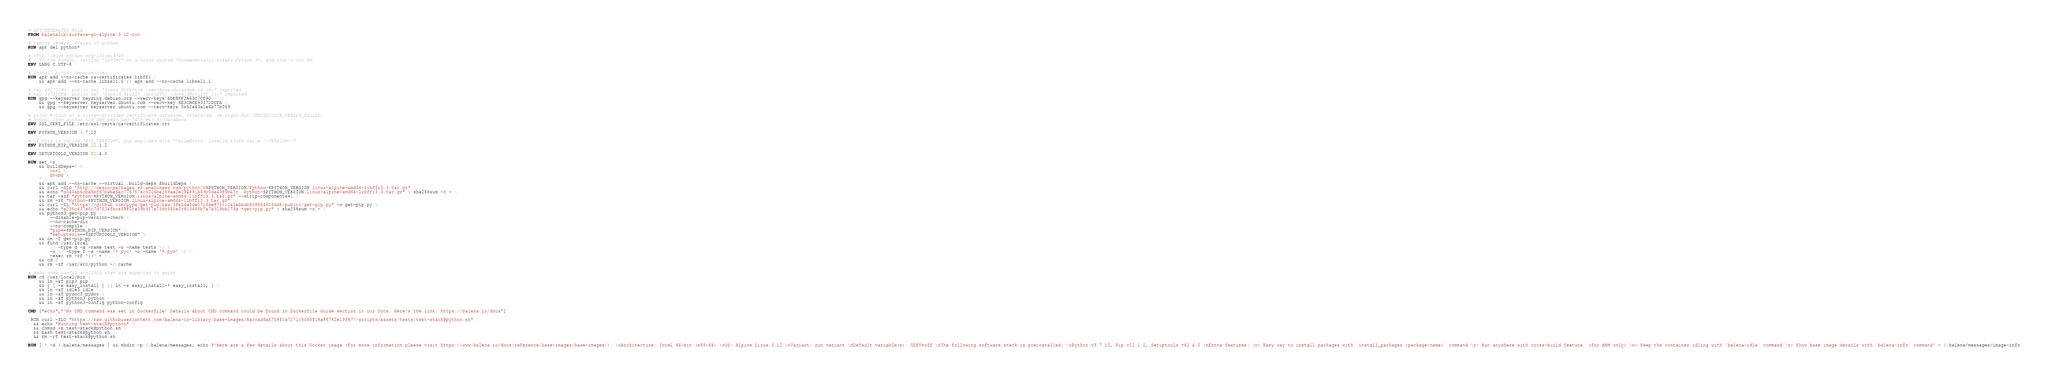Convert code to text. <code><loc_0><loc_0><loc_500><loc_500><_Dockerfile_># AUTOGENERATED FILE
FROM balenalib/surface-go-alpine:3.12-run

# remove several traces of python
RUN apk del python*

# http://bugs.python.org/issue19846
# > At the moment, setting "LANG=C" on a Linux system *fundamentally breaks Python 3*, and that's not OK.
ENV LANG C.UTF-8

# install python dependencies
RUN apk add --no-cache ca-certificates libffi \
	&& apk add --no-cache libssl1.0 || apk add --no-cache libssl1.1

# key 63C7CC90: public key "Simon McVittie <smcv@pseudorandom.co.uk>" imported
# key 3372DCFA: public key "Donald Stufft (dstufft) <donald@stufft.io>" imported
RUN gpg --keyserver keyring.debian.org --recv-keys 4DE8FF2A63C7CC90 \
	&& gpg --keyserver keyserver.ubuntu.com --recv-key 6E3CBCE93372DCFA \
	&& gpg --keyserver keyserver.ubuntu.com --recv-keys 0x52a43a1e4b77b059

# point Python at a system-provided certificate database. Otherwise, we might hit CERTIFICATE_VERIFY_FAILED.
# https://www.python.org/dev/peps/pep-0476/#trust-database
ENV SSL_CERT_FILE /etc/ssl/certs/ca-certificates.crt

ENV PYTHON_VERSION 3.7.13

# if this is called "PIP_VERSION", pip explodes with "ValueError: invalid truth value '<VERSION>'"
ENV PYTHON_PIP_VERSION 22.1.2

ENV SETUPTOOLS_VERSION 62.4.0

RUN set -x \
	&& buildDeps=' \
		curl \
		gnupg \
	' \
	&& apk add --no-cache --virtual .build-deps $buildDeps \
	&& curl -SLO "http://resin-packages.s3.amazonaws.com/python/v$PYTHON_VERSION/Python-$PYTHON_VERSION.linux-alpine-amd64-libffi3.3.tar.gz" \
	&& echo "d340ab6cba5bf87babe6ac776757ac5206be259aa2e194891b59b5da4389b47c  Python-$PYTHON_VERSION.linux-alpine-amd64-libffi3.3.tar.gz" | sha256sum -c - \
	&& tar -xzf "Python-$PYTHON_VERSION.linux-alpine-amd64-libffi3.3.tar.gz" --strip-components=1 \
	&& rm -rf "Python-$PYTHON_VERSION.linux-alpine-amd64-libffi3.3.tar.gz" \
	&& curl -SL "https://github.com/pypa/get-pip/raw/38e54e5de07c66e875c11a1ebbdb938854625dd8/public/get-pip.py" -o get-pip.py \
    && echo "e235c437e5c7d7524fbce3880ca39b917a73dc565e0c813465b7a7a329bb279a *get-pip.py" | sha256sum -c - \
    && python3 get-pip.py \
        --disable-pip-version-check \
        --no-cache-dir \
        --no-compile \
        "pip==$PYTHON_PIP_VERSION" \
        "setuptools==$SETUPTOOLS_VERSION" \
	&& rm -f get-pip.py \
	&& find /usr/local \
		\( -type d -a -name test -o -name tests \) \
		-o \( -type f -a -name '*.pyc' -o -name '*.pyo' \) \
		-exec rm -rf '{}' + \
	&& cd / \
	&& rm -rf /usr/src/python ~/.cache

# make some useful symlinks that are expected to exist
RUN cd /usr/local/bin \
	&& ln -sf pip3 pip \
	&& { [ -e easy_install ] || ln -s easy_install-* easy_install; } \
	&& ln -sf idle3 idle \
	&& ln -sf pydoc3 pydoc \
	&& ln -sf python3 python \
	&& ln -sf python3-config python-config

CMD ["echo","'No CMD command was set in Dockerfile! Details about CMD command could be found in Dockerfile Guide section in our Docs. Here's the link: https://balena.io/docs"]

 RUN curl -SLO "https://raw.githubusercontent.com/balena-io-library/base-images/8accad6af708fca7271c5c65f18a86782e19f877/scripts/assets/tests/test-stack@python.sh" \
  && echo "Running test-stack@python" \
  && chmod +x test-stack@python.sh \
  && bash test-stack@python.sh \
  && rm -rf test-stack@python.sh 

RUN [ ! -d /.balena/messages ] && mkdir -p /.balena/messages; echo $'Here are a few details about this Docker image (For more information please visit https://www.balena.io/docs/reference/base-images/base-images/): \nArchitecture: Intel 64-bit (x86-64) \nOS: Alpine Linux 3.12 \nVariant: run variant \nDefault variable(s): UDEV=off \nThe following software stack is preinstalled: \nPython v3.7.13, Pip v22.1.2, Setuptools v62.4.0 \nExtra features: \n- Easy way to install packages with `install_packages <package-name>` command \n- Run anywhere with cross-build feature  (for ARM only) \n- Keep the container idling with `balena-idle` command \n- Show base image details with `balena-info` command' > /.balena/messages/image-info</code> 